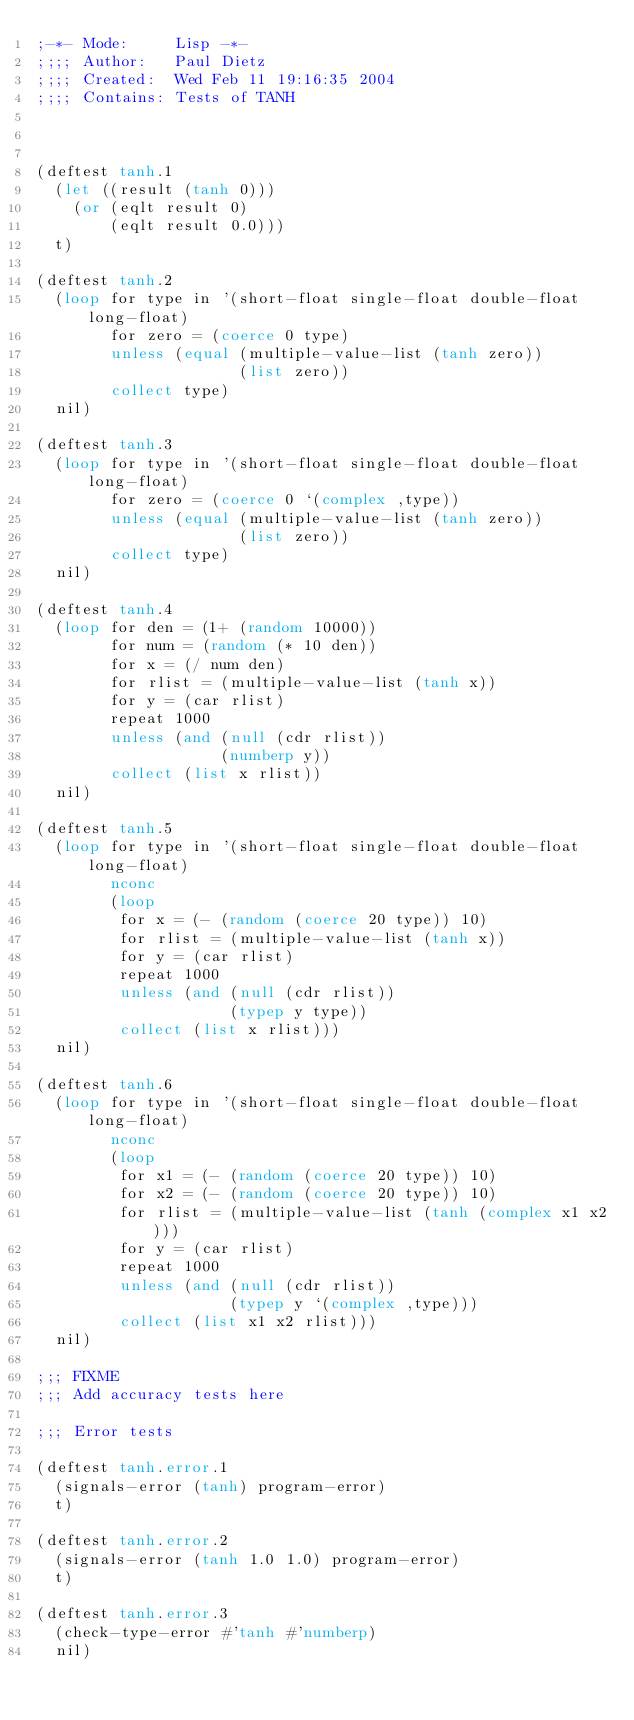<code> <loc_0><loc_0><loc_500><loc_500><_Lisp_>;-*- Mode:     Lisp -*-
;;;; Author:   Paul Dietz
;;;; Created:  Wed Feb 11 19:16:35 2004
;;;; Contains: Tests of TANH



(deftest tanh.1
  (let ((result (tanh 0)))
    (or (eqlt result 0)
        (eqlt result 0.0)))
  t)

(deftest tanh.2
  (loop for type in '(short-float single-float double-float long-float)
        for zero = (coerce 0 type)
        unless (equal (multiple-value-list (tanh zero))
                      (list zero))
        collect type)
  nil)

(deftest tanh.3
  (loop for type in '(short-float single-float double-float long-float)
        for zero = (coerce 0 `(complex ,type))
        unless (equal (multiple-value-list (tanh zero))
                      (list zero))
        collect type)
  nil)

(deftest tanh.4
  (loop for den = (1+ (random 10000))
        for num = (random (* 10 den))
        for x = (/ num den)
        for rlist = (multiple-value-list (tanh x))
        for y = (car rlist)
        repeat 1000
        unless (and (null (cdr rlist))
                    (numberp y))
        collect (list x rlist))
  nil)

(deftest tanh.5
  (loop for type in '(short-float single-float double-float long-float)
        nconc
        (loop
         for x = (- (random (coerce 20 type)) 10)
         for rlist = (multiple-value-list (tanh x))
         for y = (car rlist)
         repeat 1000
         unless (and (null (cdr rlist))
                     (typep y type))
         collect (list x rlist)))
  nil)

(deftest tanh.6
  (loop for type in '(short-float single-float double-float long-float)
        nconc
        (loop
         for x1 = (- (random (coerce 20 type)) 10)
         for x2 = (- (random (coerce 20 type)) 10)
         for rlist = (multiple-value-list (tanh (complex x1 x2)))
         for y = (car rlist)
         repeat 1000
         unless (and (null (cdr rlist))
                     (typep y `(complex ,type)))
         collect (list x1 x2 rlist)))
  nil)

;;; FIXME
;;; Add accuracy tests here

;;; Error tests

(deftest tanh.error.1
  (signals-error (tanh) program-error)
  t)

(deftest tanh.error.2
  (signals-error (tanh 1.0 1.0) program-error)
  t)

(deftest tanh.error.3
  (check-type-error #'tanh #'numberp)
  nil)
</code> 